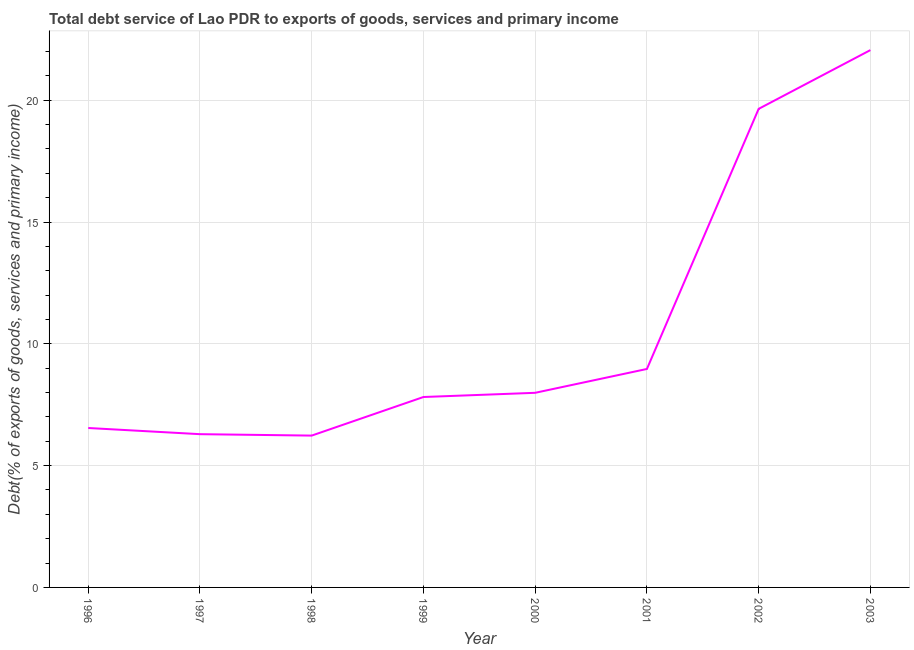What is the total debt service in 2003?
Your answer should be compact. 22.06. Across all years, what is the maximum total debt service?
Provide a short and direct response. 22.06. Across all years, what is the minimum total debt service?
Offer a terse response. 6.23. What is the sum of the total debt service?
Provide a short and direct response. 85.55. What is the difference between the total debt service in 1999 and 2003?
Keep it short and to the point. -14.24. What is the average total debt service per year?
Your answer should be very brief. 10.69. What is the median total debt service?
Your answer should be very brief. 7.9. Do a majority of the years between 1996 and 2003 (inclusive) have total debt service greater than 12 %?
Give a very brief answer. No. What is the ratio of the total debt service in 1996 to that in 2002?
Offer a terse response. 0.33. What is the difference between the highest and the second highest total debt service?
Your answer should be compact. 2.41. What is the difference between the highest and the lowest total debt service?
Your response must be concise. 15.82. In how many years, is the total debt service greater than the average total debt service taken over all years?
Give a very brief answer. 2. How many years are there in the graph?
Give a very brief answer. 8. What is the difference between two consecutive major ticks on the Y-axis?
Provide a succinct answer. 5. Are the values on the major ticks of Y-axis written in scientific E-notation?
Keep it short and to the point. No. Does the graph contain any zero values?
Provide a short and direct response. No. Does the graph contain grids?
Ensure brevity in your answer.  Yes. What is the title of the graph?
Give a very brief answer. Total debt service of Lao PDR to exports of goods, services and primary income. What is the label or title of the Y-axis?
Ensure brevity in your answer.  Debt(% of exports of goods, services and primary income). What is the Debt(% of exports of goods, services and primary income) of 1996?
Give a very brief answer. 6.54. What is the Debt(% of exports of goods, services and primary income) in 1997?
Offer a terse response. 6.29. What is the Debt(% of exports of goods, services and primary income) in 1998?
Your answer should be compact. 6.23. What is the Debt(% of exports of goods, services and primary income) in 1999?
Ensure brevity in your answer.  7.82. What is the Debt(% of exports of goods, services and primary income) in 2000?
Offer a very short reply. 7.99. What is the Debt(% of exports of goods, services and primary income) of 2001?
Offer a very short reply. 8.97. What is the Debt(% of exports of goods, services and primary income) in 2002?
Keep it short and to the point. 19.65. What is the Debt(% of exports of goods, services and primary income) of 2003?
Your answer should be very brief. 22.06. What is the difference between the Debt(% of exports of goods, services and primary income) in 1996 and 1997?
Provide a succinct answer. 0.25. What is the difference between the Debt(% of exports of goods, services and primary income) in 1996 and 1998?
Offer a very short reply. 0.31. What is the difference between the Debt(% of exports of goods, services and primary income) in 1996 and 1999?
Give a very brief answer. -1.27. What is the difference between the Debt(% of exports of goods, services and primary income) in 1996 and 2000?
Offer a very short reply. -1.44. What is the difference between the Debt(% of exports of goods, services and primary income) in 1996 and 2001?
Your answer should be compact. -2.42. What is the difference between the Debt(% of exports of goods, services and primary income) in 1996 and 2002?
Make the answer very short. -13.1. What is the difference between the Debt(% of exports of goods, services and primary income) in 1996 and 2003?
Give a very brief answer. -15.51. What is the difference between the Debt(% of exports of goods, services and primary income) in 1997 and 1998?
Provide a succinct answer. 0.06. What is the difference between the Debt(% of exports of goods, services and primary income) in 1997 and 1999?
Your response must be concise. -1.53. What is the difference between the Debt(% of exports of goods, services and primary income) in 1997 and 2000?
Provide a succinct answer. -1.7. What is the difference between the Debt(% of exports of goods, services and primary income) in 1997 and 2001?
Offer a very short reply. -2.68. What is the difference between the Debt(% of exports of goods, services and primary income) in 1997 and 2002?
Ensure brevity in your answer.  -13.35. What is the difference between the Debt(% of exports of goods, services and primary income) in 1997 and 2003?
Your response must be concise. -15.77. What is the difference between the Debt(% of exports of goods, services and primary income) in 1998 and 1999?
Give a very brief answer. -1.58. What is the difference between the Debt(% of exports of goods, services and primary income) in 1998 and 2000?
Make the answer very short. -1.76. What is the difference between the Debt(% of exports of goods, services and primary income) in 1998 and 2001?
Provide a succinct answer. -2.74. What is the difference between the Debt(% of exports of goods, services and primary income) in 1998 and 2002?
Make the answer very short. -13.41. What is the difference between the Debt(% of exports of goods, services and primary income) in 1998 and 2003?
Keep it short and to the point. -15.82. What is the difference between the Debt(% of exports of goods, services and primary income) in 1999 and 2000?
Provide a short and direct response. -0.17. What is the difference between the Debt(% of exports of goods, services and primary income) in 1999 and 2001?
Your response must be concise. -1.15. What is the difference between the Debt(% of exports of goods, services and primary income) in 1999 and 2002?
Your answer should be compact. -11.83. What is the difference between the Debt(% of exports of goods, services and primary income) in 1999 and 2003?
Your answer should be compact. -14.24. What is the difference between the Debt(% of exports of goods, services and primary income) in 2000 and 2001?
Provide a succinct answer. -0.98. What is the difference between the Debt(% of exports of goods, services and primary income) in 2000 and 2002?
Offer a terse response. -11.66. What is the difference between the Debt(% of exports of goods, services and primary income) in 2000 and 2003?
Provide a succinct answer. -14.07. What is the difference between the Debt(% of exports of goods, services and primary income) in 2001 and 2002?
Your answer should be very brief. -10.68. What is the difference between the Debt(% of exports of goods, services and primary income) in 2001 and 2003?
Ensure brevity in your answer.  -13.09. What is the difference between the Debt(% of exports of goods, services and primary income) in 2002 and 2003?
Offer a very short reply. -2.41. What is the ratio of the Debt(% of exports of goods, services and primary income) in 1996 to that in 1997?
Your answer should be very brief. 1.04. What is the ratio of the Debt(% of exports of goods, services and primary income) in 1996 to that in 1999?
Offer a terse response. 0.84. What is the ratio of the Debt(% of exports of goods, services and primary income) in 1996 to that in 2000?
Keep it short and to the point. 0.82. What is the ratio of the Debt(% of exports of goods, services and primary income) in 1996 to that in 2001?
Provide a short and direct response. 0.73. What is the ratio of the Debt(% of exports of goods, services and primary income) in 1996 to that in 2002?
Ensure brevity in your answer.  0.33. What is the ratio of the Debt(% of exports of goods, services and primary income) in 1996 to that in 2003?
Make the answer very short. 0.3. What is the ratio of the Debt(% of exports of goods, services and primary income) in 1997 to that in 1998?
Your response must be concise. 1.01. What is the ratio of the Debt(% of exports of goods, services and primary income) in 1997 to that in 1999?
Keep it short and to the point. 0.81. What is the ratio of the Debt(% of exports of goods, services and primary income) in 1997 to that in 2000?
Provide a succinct answer. 0.79. What is the ratio of the Debt(% of exports of goods, services and primary income) in 1997 to that in 2001?
Your answer should be compact. 0.7. What is the ratio of the Debt(% of exports of goods, services and primary income) in 1997 to that in 2002?
Your response must be concise. 0.32. What is the ratio of the Debt(% of exports of goods, services and primary income) in 1997 to that in 2003?
Offer a very short reply. 0.28. What is the ratio of the Debt(% of exports of goods, services and primary income) in 1998 to that in 1999?
Your answer should be very brief. 0.8. What is the ratio of the Debt(% of exports of goods, services and primary income) in 1998 to that in 2000?
Ensure brevity in your answer.  0.78. What is the ratio of the Debt(% of exports of goods, services and primary income) in 1998 to that in 2001?
Provide a short and direct response. 0.69. What is the ratio of the Debt(% of exports of goods, services and primary income) in 1998 to that in 2002?
Your answer should be very brief. 0.32. What is the ratio of the Debt(% of exports of goods, services and primary income) in 1998 to that in 2003?
Provide a succinct answer. 0.28. What is the ratio of the Debt(% of exports of goods, services and primary income) in 1999 to that in 2000?
Provide a short and direct response. 0.98. What is the ratio of the Debt(% of exports of goods, services and primary income) in 1999 to that in 2001?
Your answer should be compact. 0.87. What is the ratio of the Debt(% of exports of goods, services and primary income) in 1999 to that in 2002?
Offer a terse response. 0.4. What is the ratio of the Debt(% of exports of goods, services and primary income) in 1999 to that in 2003?
Your response must be concise. 0.35. What is the ratio of the Debt(% of exports of goods, services and primary income) in 2000 to that in 2001?
Give a very brief answer. 0.89. What is the ratio of the Debt(% of exports of goods, services and primary income) in 2000 to that in 2002?
Offer a terse response. 0.41. What is the ratio of the Debt(% of exports of goods, services and primary income) in 2000 to that in 2003?
Ensure brevity in your answer.  0.36. What is the ratio of the Debt(% of exports of goods, services and primary income) in 2001 to that in 2002?
Offer a terse response. 0.46. What is the ratio of the Debt(% of exports of goods, services and primary income) in 2001 to that in 2003?
Give a very brief answer. 0.41. What is the ratio of the Debt(% of exports of goods, services and primary income) in 2002 to that in 2003?
Your answer should be compact. 0.89. 